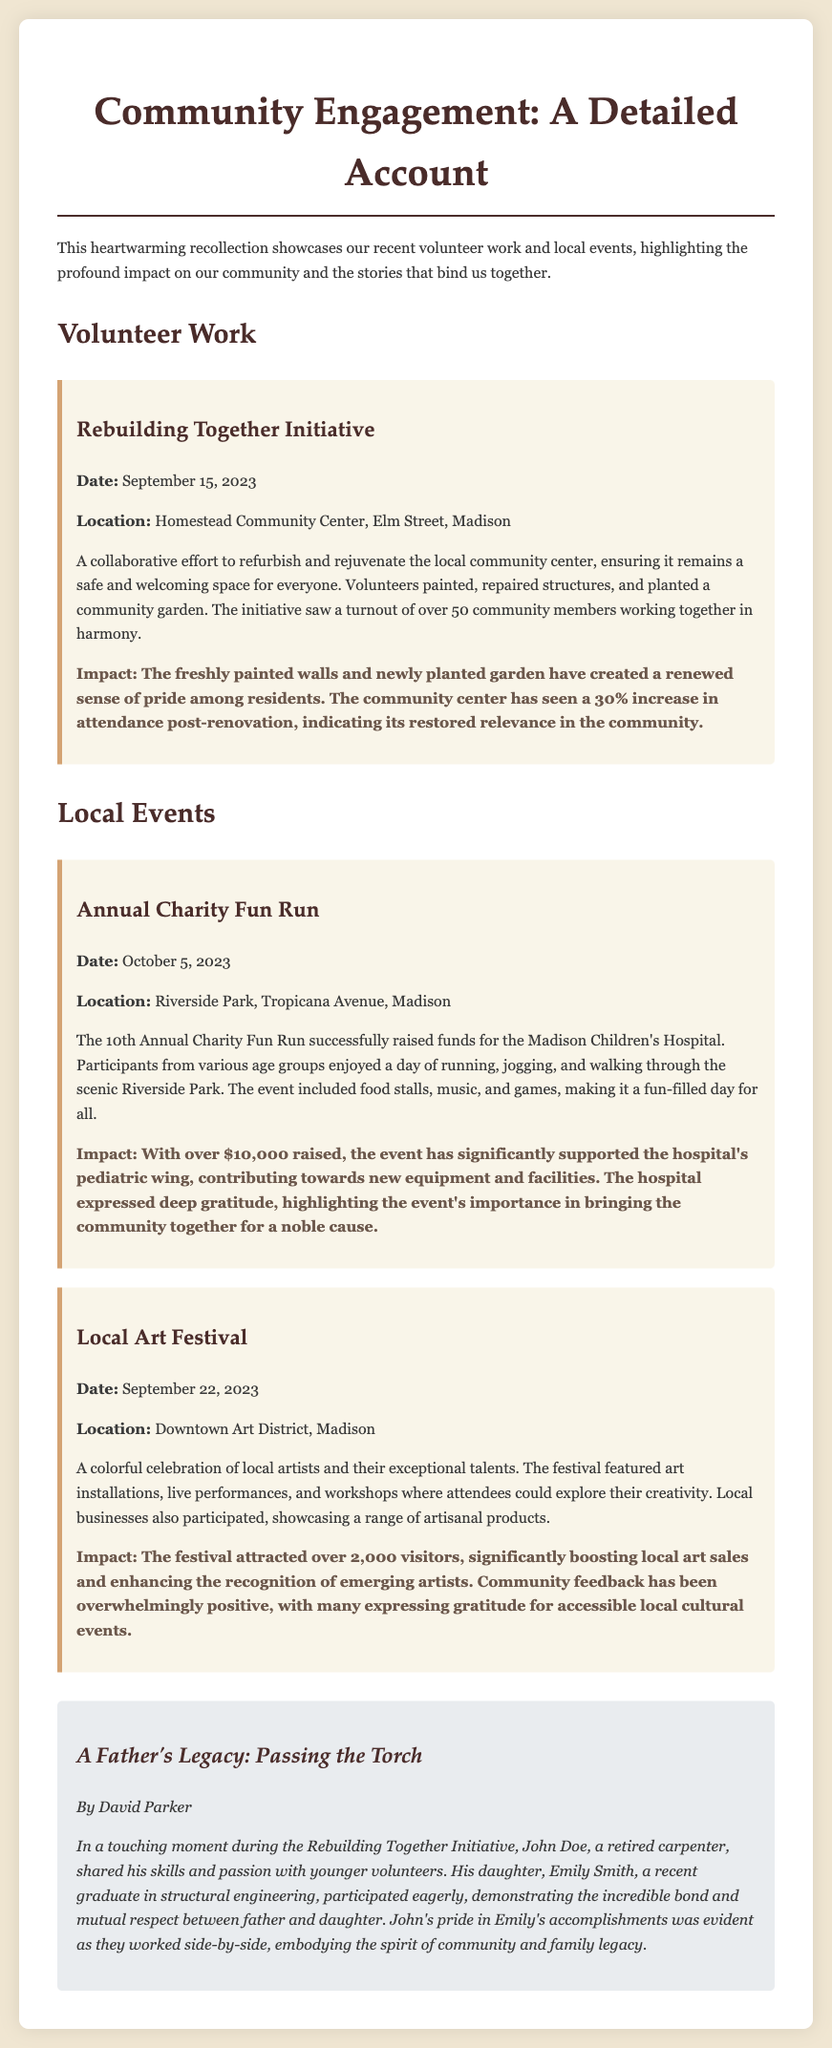What was the date of the Rebuilding Together Initiative? The document mentions that the Rebuilding Together Initiative took place on September 15, 2023.
Answer: September 15, 2023 How many community members participated in the Rebuilding Together Initiative? It states that over 50 community members worked together during the initiative.
Answer: Over 50 What was the total amount raised during the Annual Charity Fun Run? The document indicates that the event raised over $10,000 for the Madison Children's Hospital.
Answer: Over $10,000 Where was the Local Art Festival held? It specifies that the Local Art Festival took place in the Downtown Art District of Madison.
Answer: Downtown Art District, Madison What percentage increase in attendance did the community center see after renovations? The document mentions a 30% increase in attendance post-renovation.
Answer: 30% Which volunteer shared his skills with younger volunteers during the initiative? The document notes that John Doe, a retired carpenter, shared his skills with younger volunteers.
Answer: John Doe How many visitors attended the Local Art Festival? It states that the festival attracted over 2,000 visitors.
Answer: Over 2,000 What kind of bond was demonstrated during the Rebuilding Together Initiative? The document highlights a bond of mutual respect and pride between father and daughter, as seen with John Doe and Emily Smith.
Answer: Mutual respect and pride What type of event was the Annual Charity Fun Run described as? The document describes it as a charity event aimed at raising funds for the children's hospital.
Answer: Charity event 